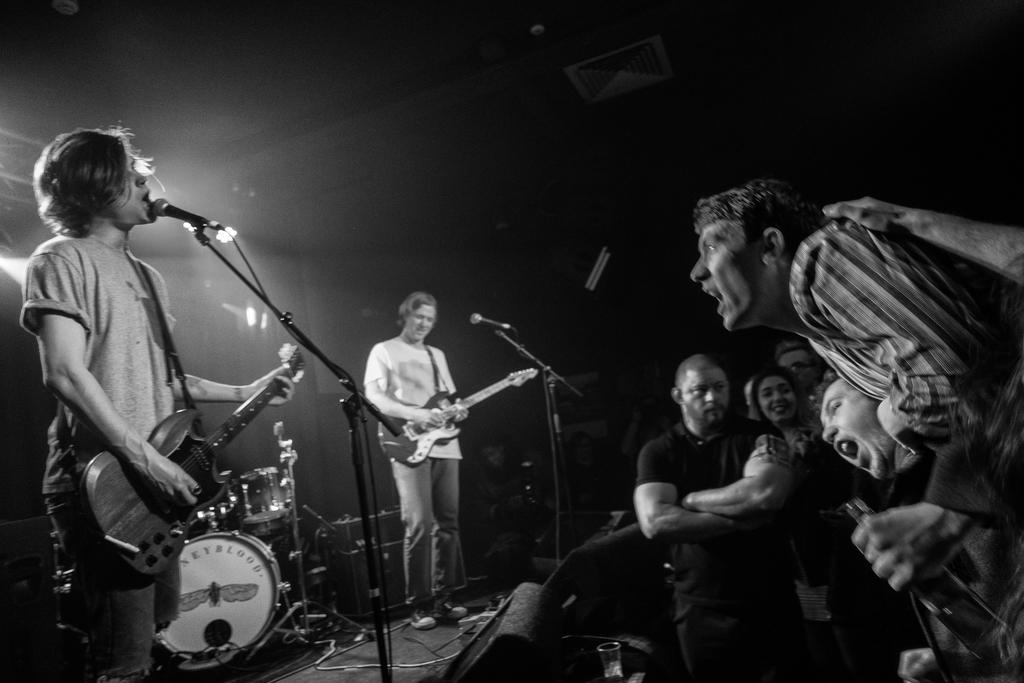How many people are in the image? There are two people in the image. What are the two people doing in the image? The two people are standing in front of a mic and playing guitar. Can you describe the audience in the image? There is a group of people in front of the two people, and they are standing and shouting at them. What type of government is being discussed by the two people in the image? There is no discussion of government in the image; the two people are playing guitar. How many knees are visible in the image? The number of knees visible in the image cannot be determined from the provided facts, as the focus is on the people and their actions. 